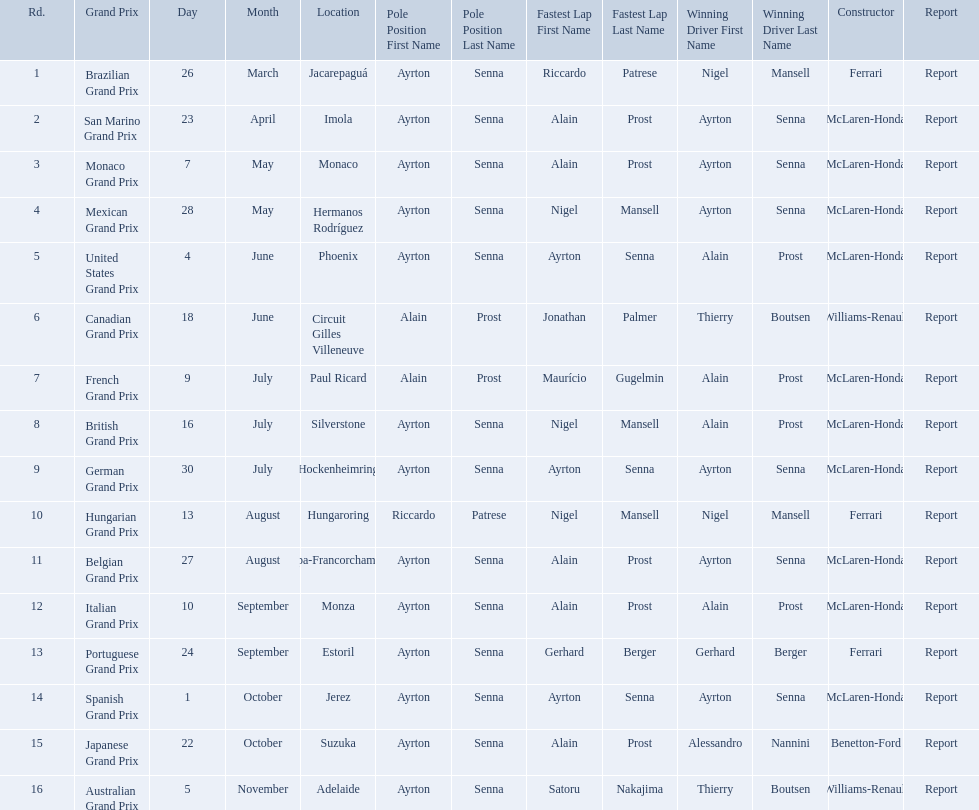Who are the constructors in the 1989 formula one season? Ferrari, McLaren-Honda, McLaren-Honda, McLaren-Honda, McLaren-Honda, Williams-Renault, McLaren-Honda, McLaren-Honda, McLaren-Honda, Ferrari, McLaren-Honda, McLaren-Honda, Ferrari, McLaren-Honda, Benetton-Ford, Williams-Renault. On what date was bennington ford the constructor? 22 October. What was the race on october 22? Japanese Grand Prix. Who won the spanish grand prix? McLaren-Honda. Who won the italian grand prix? McLaren-Honda. What grand prix did benneton-ford win? Japanese Grand Prix. What are all of the grand prix run in the 1989 formula one season? Brazilian Grand Prix, San Marino Grand Prix, Monaco Grand Prix, Mexican Grand Prix, United States Grand Prix, Canadian Grand Prix, French Grand Prix, British Grand Prix, German Grand Prix, Hungarian Grand Prix, Belgian Grand Prix, Italian Grand Prix, Portuguese Grand Prix, Spanish Grand Prix, Japanese Grand Prix, Australian Grand Prix. Of those 1989 formula one grand prix, which were run in october? Spanish Grand Prix, Japanese Grand Prix, Australian Grand Prix. Of those 1989 formula one grand prix run in october, which was the only one to be won by benetton-ford? Japanese Grand Prix. 